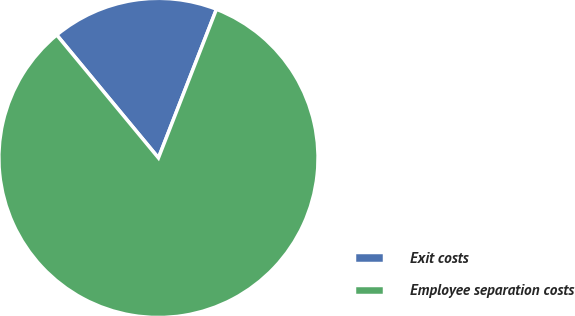<chart> <loc_0><loc_0><loc_500><loc_500><pie_chart><fcel>Exit costs<fcel>Employee separation costs<nl><fcel>16.92%<fcel>83.08%<nl></chart> 